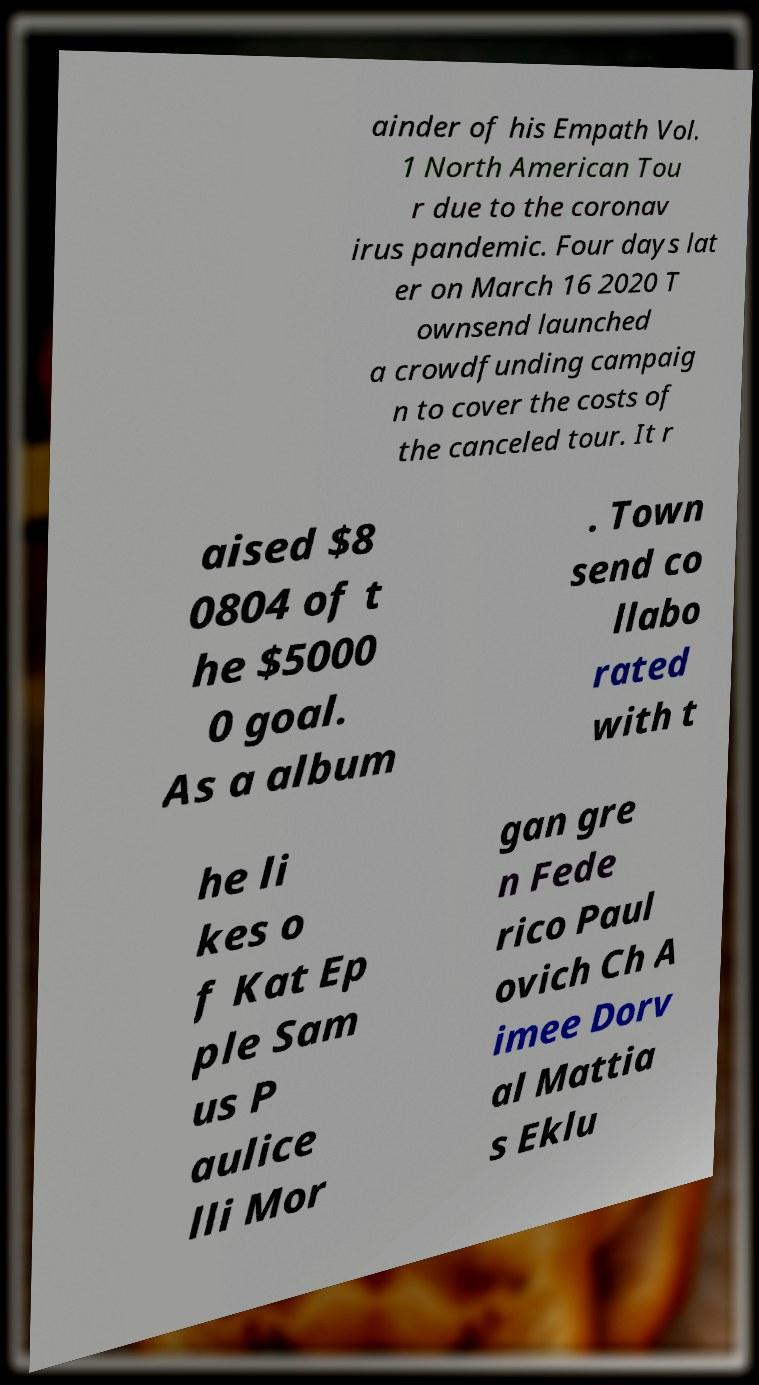Please read and relay the text visible in this image. What does it say? ainder of his Empath Vol. 1 North American Tou r due to the coronav irus pandemic. Four days lat er on March 16 2020 T ownsend launched a crowdfunding campaig n to cover the costs of the canceled tour. It r aised $8 0804 of t he $5000 0 goal. As a album . Town send co llabo rated with t he li kes o f Kat Ep ple Sam us P aulice lli Mor gan gre n Fede rico Paul ovich Ch A imee Dorv al Mattia s Eklu 